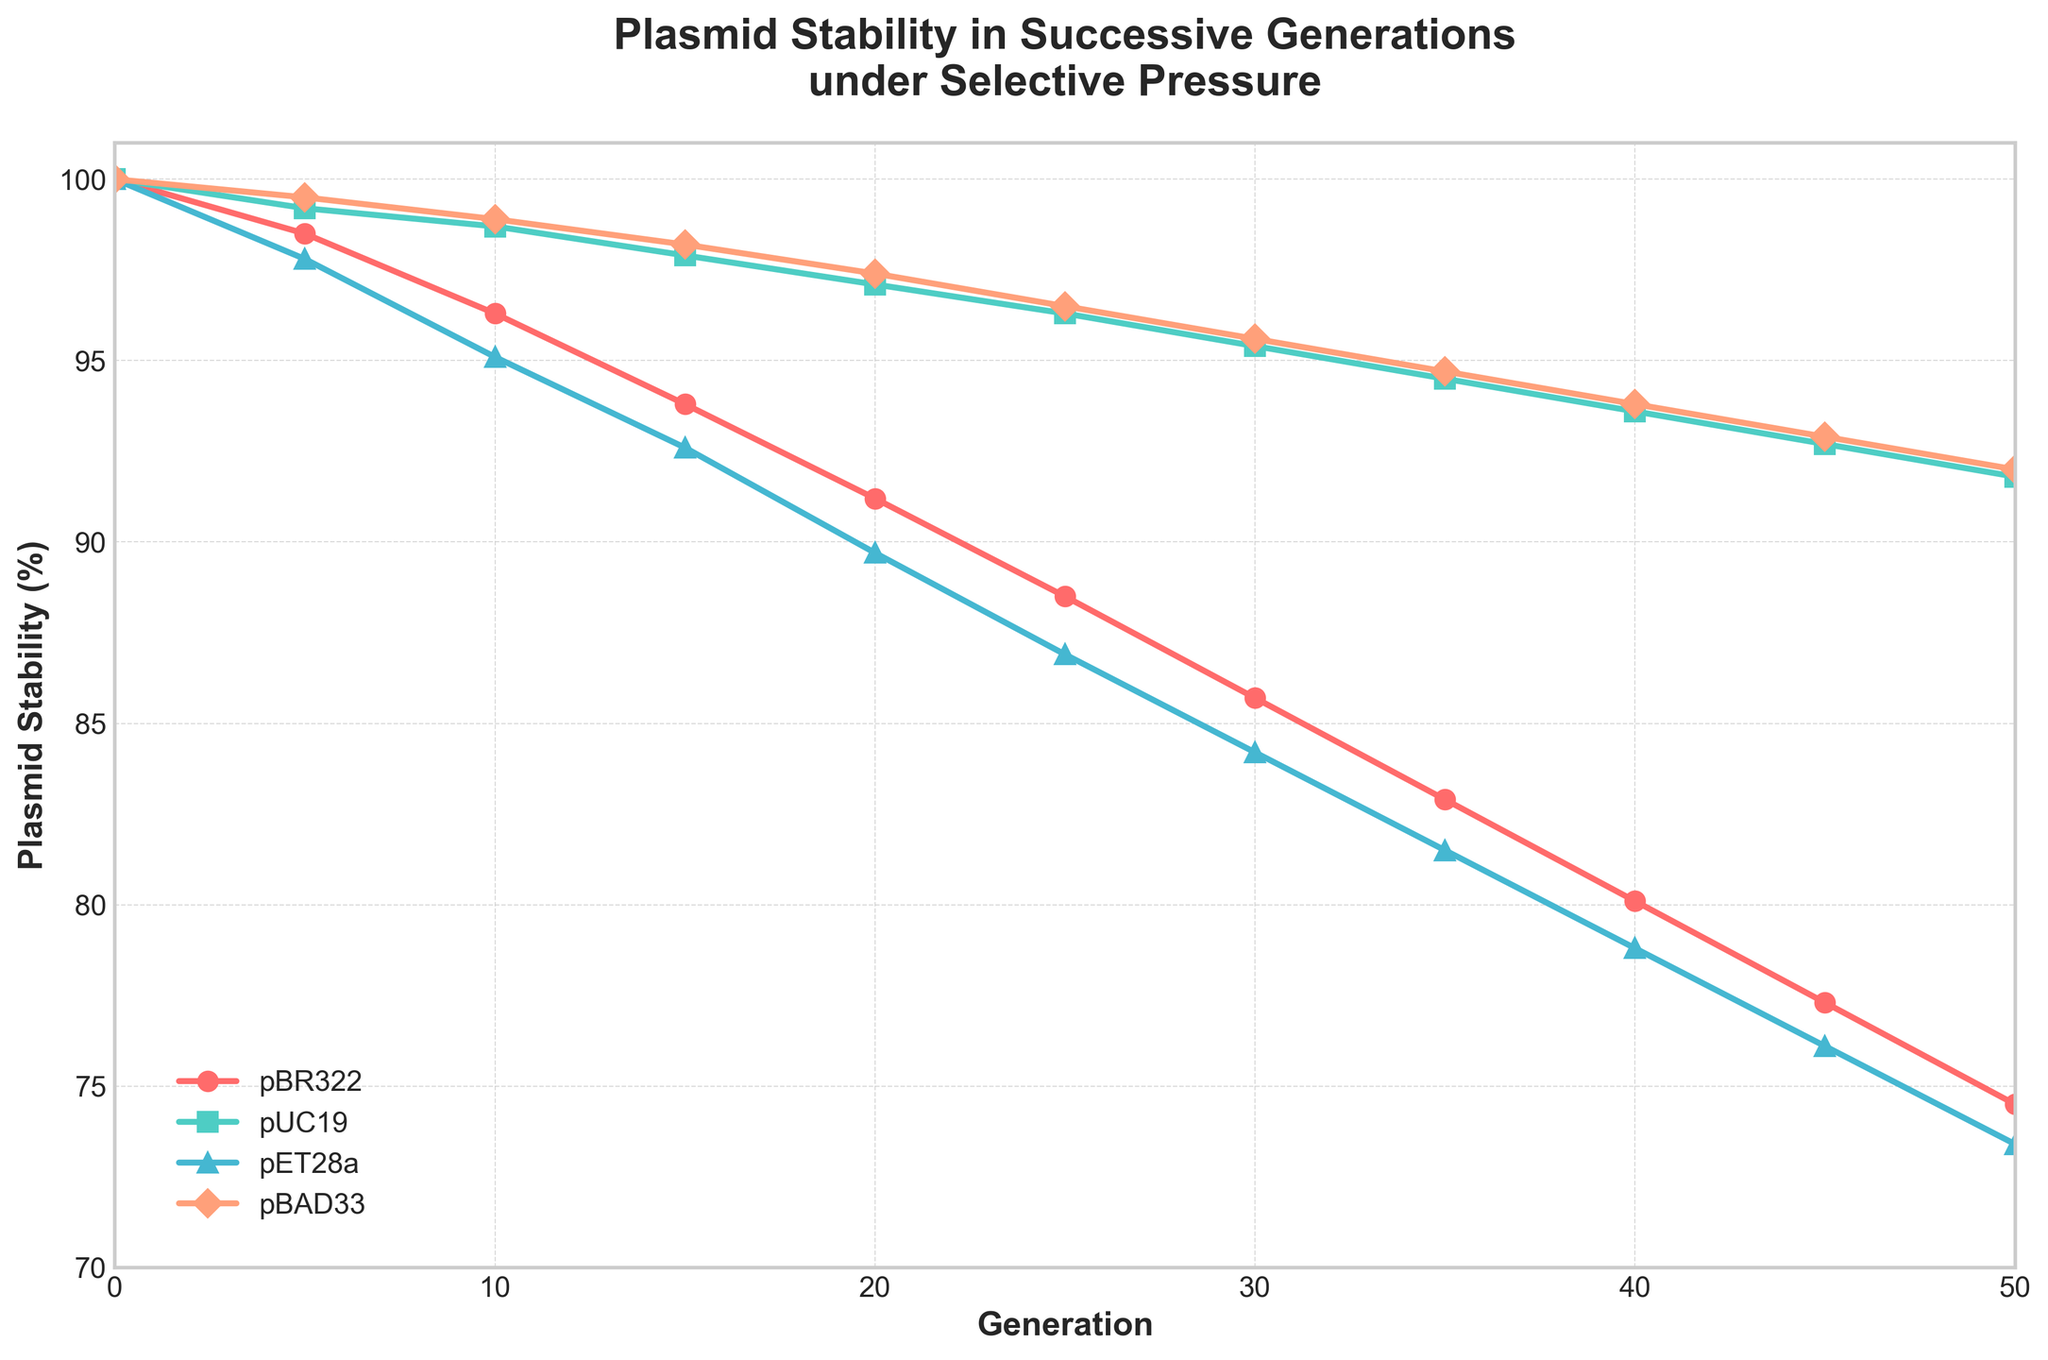What is the plasmid stability of pBR322 with Ampicillin at generation 20? Look at the data point for the pBR322 line, represented in red, at generation 20. The value on the Y-axis corresponding to this generation is 91.2
Answer: 91.2 How does the plasmid stability of pET28a with Tetracycline change between generation 10 and 30? Find the value for pET28a at generations 10 and 30. The initial value is 95.1 and the final value is 84.2. Subtract the final value from the initial value: 95.1 - 84.2 = 10.9
Answer: Decreased by 10.9 Which plasmid (except for pBR322) shows the highest stability at generation 50? Compare the data points for pUC19, pET28a, and pBAD33 at generation 50. The values are: pUC19 (91.8), pET28a (73.4), and pBAD33 (92.0). The highest of these is pBAD33 with 92.0
Answer: pBAD33 (Chloramphenicol) What's the average plasmid stability of pUC19 with Kanamycin over the first 3 recorded generations (0, 5, 10)? Sum the values of pUC19 at generations 0, 5, and 10, then divide by 3. (100 + 99.2 + 98.7) / 3 = 99.3
Answer: 99.3 Between generations 0 and 50, which plasmid shows the largest decline in stability? Calculate the difference between generation 0 and 50 for all plasmids: pBR322 (100 - 74.5 = 25.5), pUC19 (100 - 91.8 = 8.2), pET28a (100 - 73.4 = 26.6), pBAD33 (100 - 92 = 8). The largest difference is for pET28a (26.6)
Answer: pET28a (Tetracycline) At which generation do all the plasmids show the highest stability, excluding generation 0? Visually compare the lines at each generation from 5 onward. Observe which generation has the highest average values overall. Generation 5 has pBR322 (98.5), pUC19 (99.2), pET28a (97.8), pBAD33 (99.5). Sum these: 98.5 + 99.2 + 97.8 + 99.5 = 395. Compare to sums at other generations. Generation 5 shows the highest overall values
Answer: Generation 5 What is the difference in plasmid stability between pUC19 and pBR322 at generation 35? Look at the values for both pUC19 and pBR322 at generation 35. pUC19 has 94.5, and pBR322 has 82.9. Subtract these values: 94.5 - 82.9 = 11.6
Answer: 11.6 